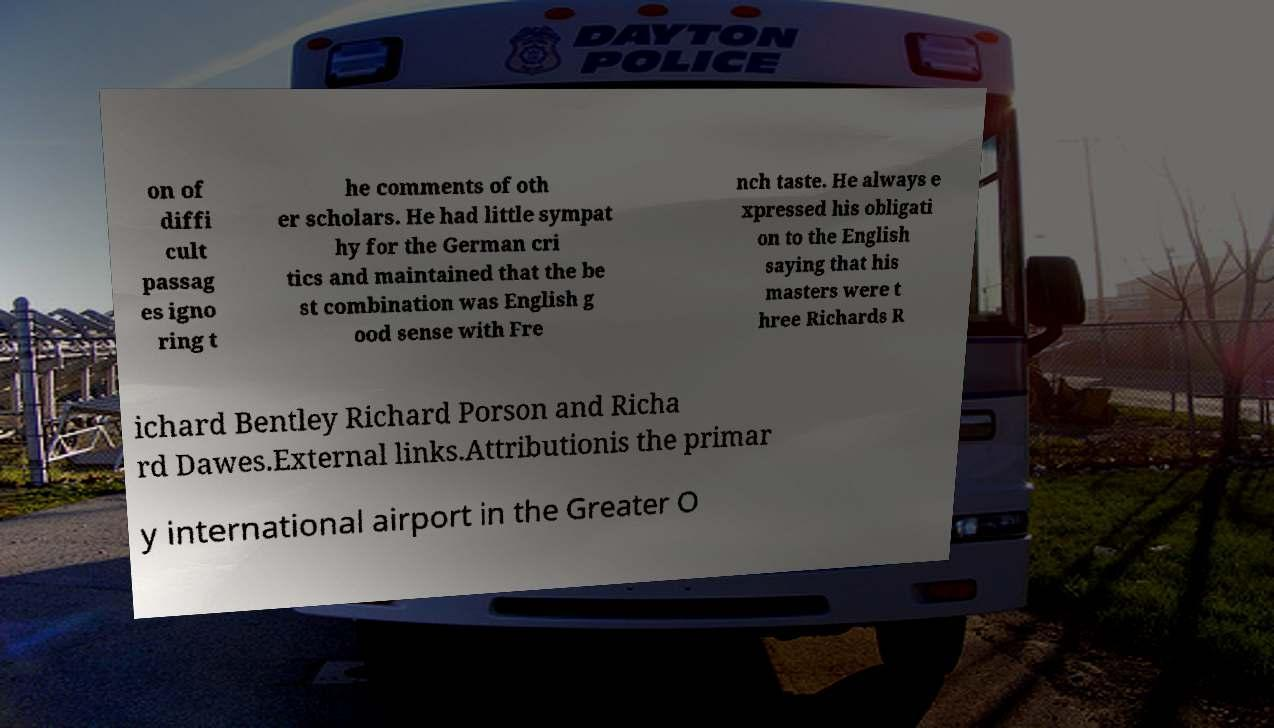Please identify and transcribe the text found in this image. on of diffi cult passag es igno ring t he comments of oth er scholars. He had little sympat hy for the German cri tics and maintained that the be st combination was English g ood sense with Fre nch taste. He always e xpressed his obligati on to the English saying that his masters were t hree Richards R ichard Bentley Richard Porson and Richa rd Dawes.External links.Attributionis the primar y international airport in the Greater O 